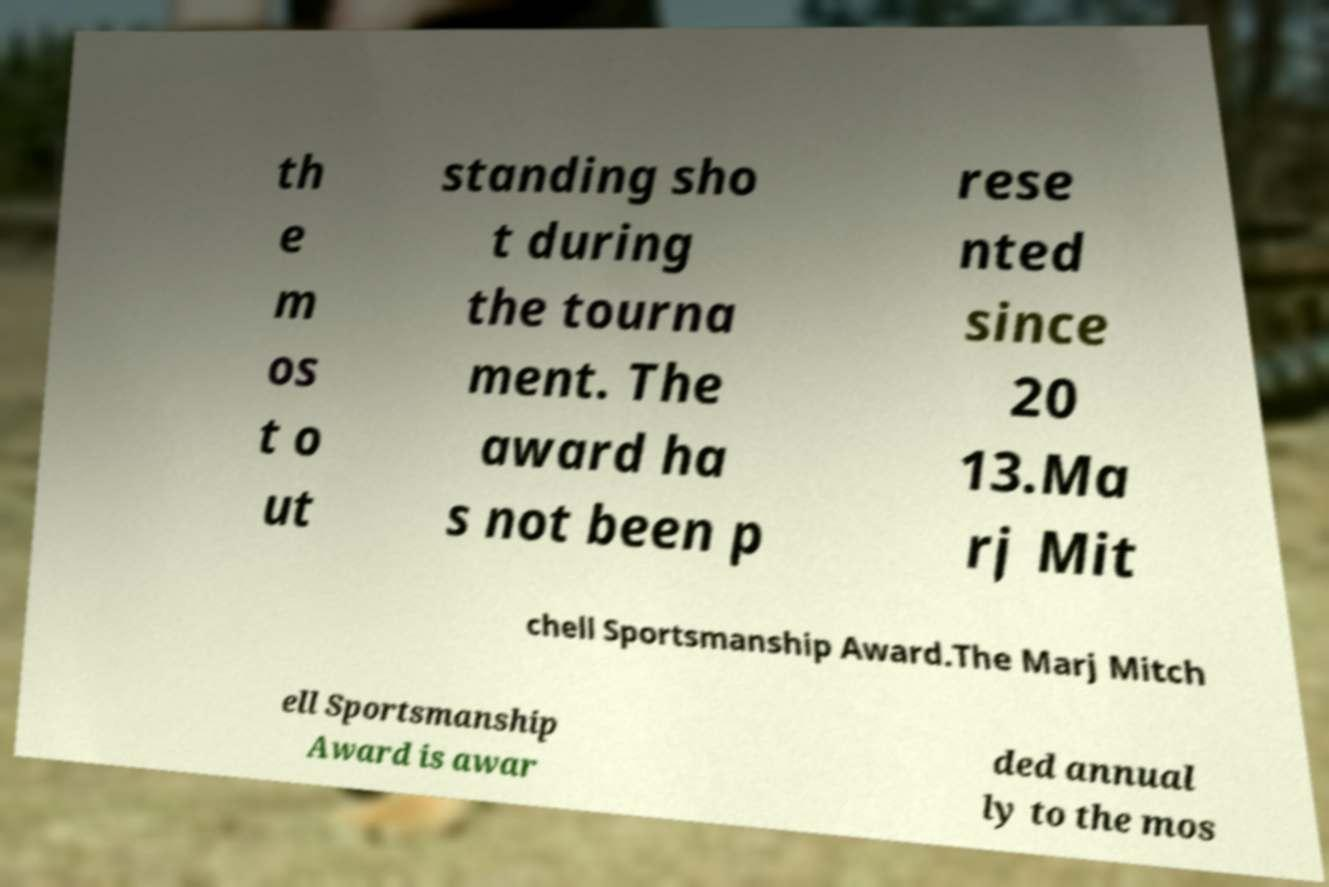Could you extract and type out the text from this image? th e m os t o ut standing sho t during the tourna ment. The award ha s not been p rese nted since 20 13.Ma rj Mit chell Sportsmanship Award.The Marj Mitch ell Sportsmanship Award is awar ded annual ly to the mos 